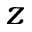Convert formula to latex. <formula><loc_0><loc_0><loc_500><loc_500>z</formula> 